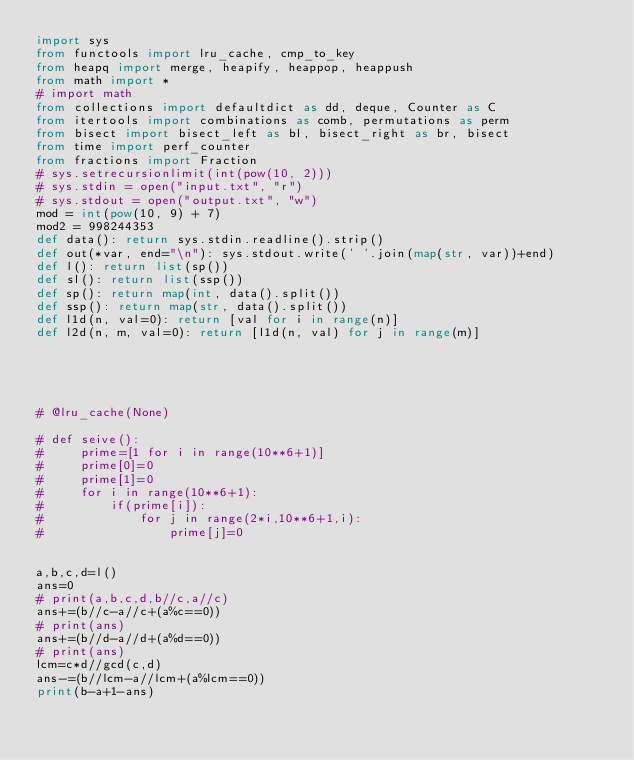<code> <loc_0><loc_0><loc_500><loc_500><_Python_>import sys
from functools import lru_cache, cmp_to_key
from heapq import merge, heapify, heappop, heappush
from math import *
# import math
from collections import defaultdict as dd, deque, Counter as C
from itertools import combinations as comb, permutations as perm
from bisect import bisect_left as bl, bisect_right as br, bisect
from time import perf_counter
from fractions import Fraction
# sys.setrecursionlimit(int(pow(10, 2)))
# sys.stdin = open("input.txt", "r")
# sys.stdout = open("output.txt", "w")
mod = int(pow(10, 9) + 7)
mod2 = 998244353
def data(): return sys.stdin.readline().strip()
def out(*var, end="\n"): sys.stdout.write(' '.join(map(str, var))+end)
def l(): return list(sp())
def sl(): return list(ssp())
def sp(): return map(int, data().split())
def ssp(): return map(str, data().split())
def l1d(n, val=0): return [val for i in range(n)]
def l2d(n, m, val=0): return [l1d(n, val) for j in range(m)]





# @lru_cache(None)

# def seive():
#     prime=[1 for i in range(10**6+1)]
#     prime[0]=0
#     prime[1]=0
#     for i in range(10**6+1):
#         if(prime[i]):
#             for j in range(2*i,10**6+1,i):
#                 prime[j]=0


a,b,c,d=l()
ans=0
# print(a,b,c,d,b//c,a//c)
ans+=(b//c-a//c+(a%c==0))
# print(ans)
ans+=(b//d-a//d+(a%d==0))
# print(ans)
lcm=c*d//gcd(c,d)
ans-=(b//lcm-a//lcm+(a%lcm==0))
print(b-a+1-ans)</code> 